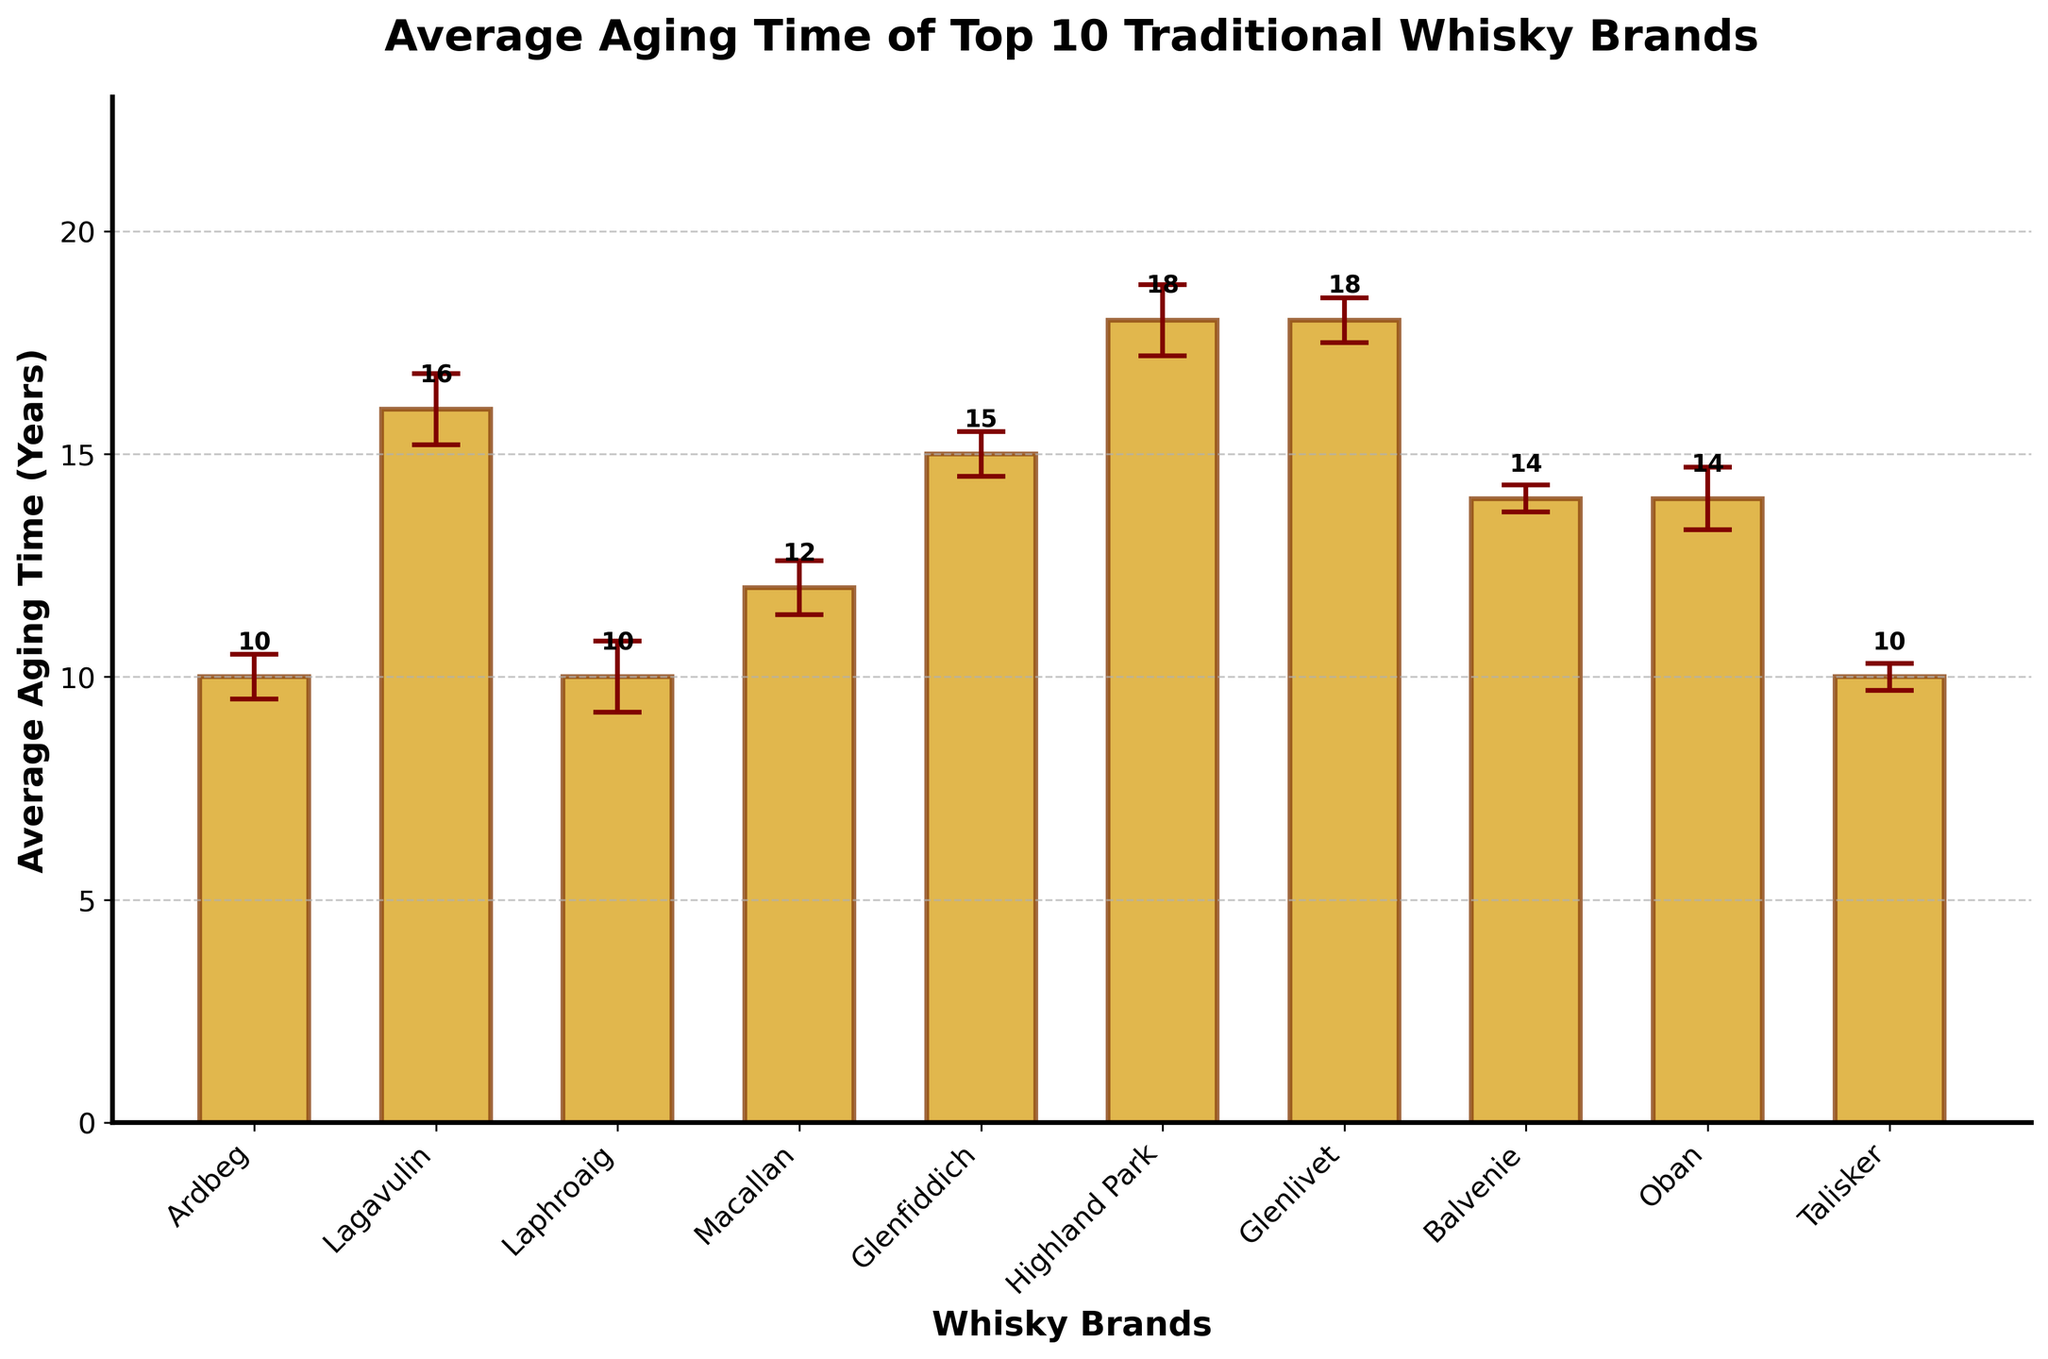What is the average aging time of Lagavulin? Look at the height of the bar for Lagavulin, which is labeled with its average aging time.
Answer: 16 years Which whisky brand has the highest average aging time? Observe the bar with the greatest height and find the corresponding brand on the x-axis.
Answer: Highland Park How many whisky brands have an average aging time greater than 15 years? Count all the bars with heights above 15 years and check the corresponding brands.
Answer: 4 Which brand has a lower average aging time, Ardbeg or Macallan? Compare the heights of the bars for Ardbeg and Macallan.
Answer: Ardbeg What is the title of the chart? The title is displayed at the top of the chart.
Answer: Average Aging Time of Top 10 Traditional Whisky Brands What is the difference in average aging time between Glenlivet and Balvenie? Look at the heights of the bars for Glenlivet and Balvenie, then calculate the difference. (18 - 14)
Answer: 4 years Which brand has the smallest error margin in its average aging time? Find the bar with the smallest error bars (confidence interval).
Answer: Balvenie Is Talisker's average aging time within the same range as Oban's? Compare the average aging time of Talisker to the lower and upper confidence intervals of Oban.
Answer: No What is the confidence interval for Laphroaig's average aging time? Look for the length of the error bars extending from Laphroaig's bar.
Answer: 9.2 - 10.8 years How many brands have an average aging time of exactly 10 years? Count the bars with labels indicating exactly 10 years.
Answer: 3 